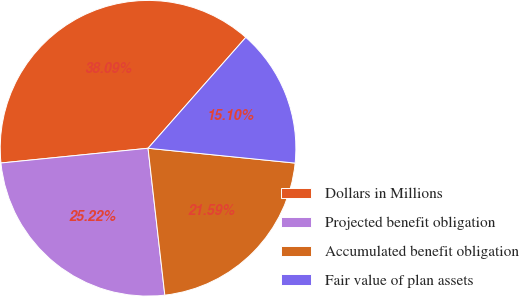<chart> <loc_0><loc_0><loc_500><loc_500><pie_chart><fcel>Dollars in Millions<fcel>Projected benefit obligation<fcel>Accumulated benefit obligation<fcel>Fair value of plan assets<nl><fcel>38.09%<fcel>25.22%<fcel>21.59%<fcel>15.1%<nl></chart> 